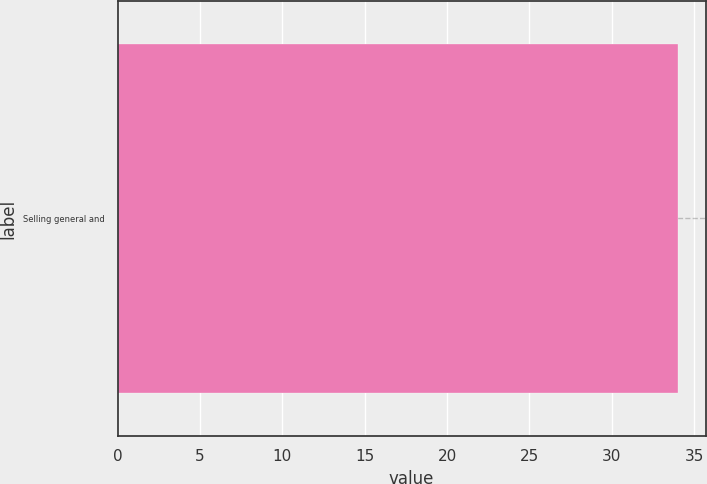<chart> <loc_0><loc_0><loc_500><loc_500><bar_chart><fcel>Selling general and<nl><fcel>34<nl></chart> 